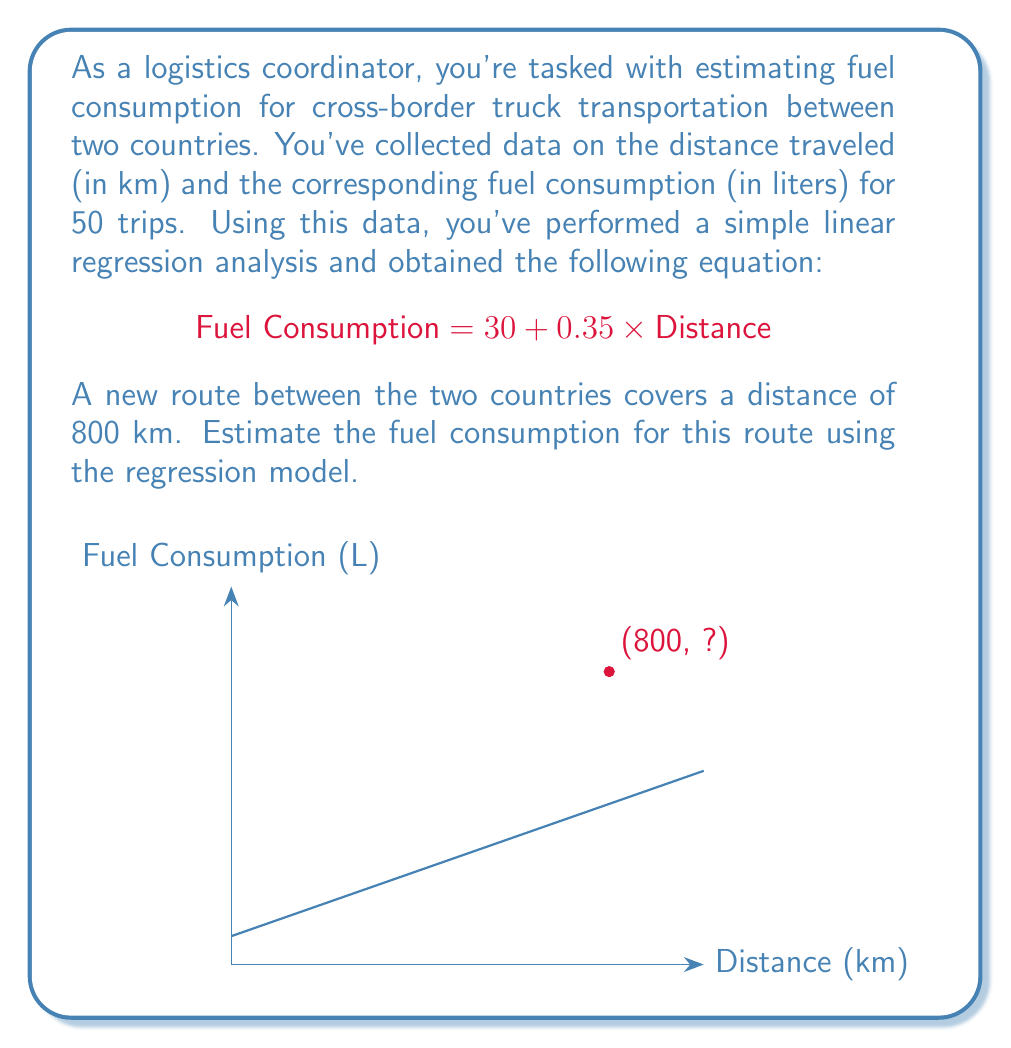Show me your answer to this math problem. To estimate the fuel consumption for the new 800 km route, we'll use the linear regression equation provided:

$$\text{Fuel Consumption} = 30 + 0.35 \times \text{Distance}$$

Let's break down the solution step-by-step:

1) We know the distance for the new route is 800 km.

2) Substitute this value into the equation:
   $$\text{Fuel Consumption} = 30 + 0.35 \times 800$$

3) Perform the multiplication:
   $$\text{Fuel Consumption} = 30 + 280$$

4) Add the terms:
   $$\text{Fuel Consumption} = 310$$

Therefore, the estimated fuel consumption for the 800 km cross-border route is 310 liters.

Interpretation:
- The y-intercept (30) represents the base fuel consumption in liters, which might account for idling time at border crossings or other fixed fuel uses.
- The slope (0.35) represents the additional fuel consumed per kilometer traveled.
- This model assumes a linear relationship between distance and fuel consumption, which is a simplification but often provides a reasonable estimate for planning purposes.
Answer: 310 liters 